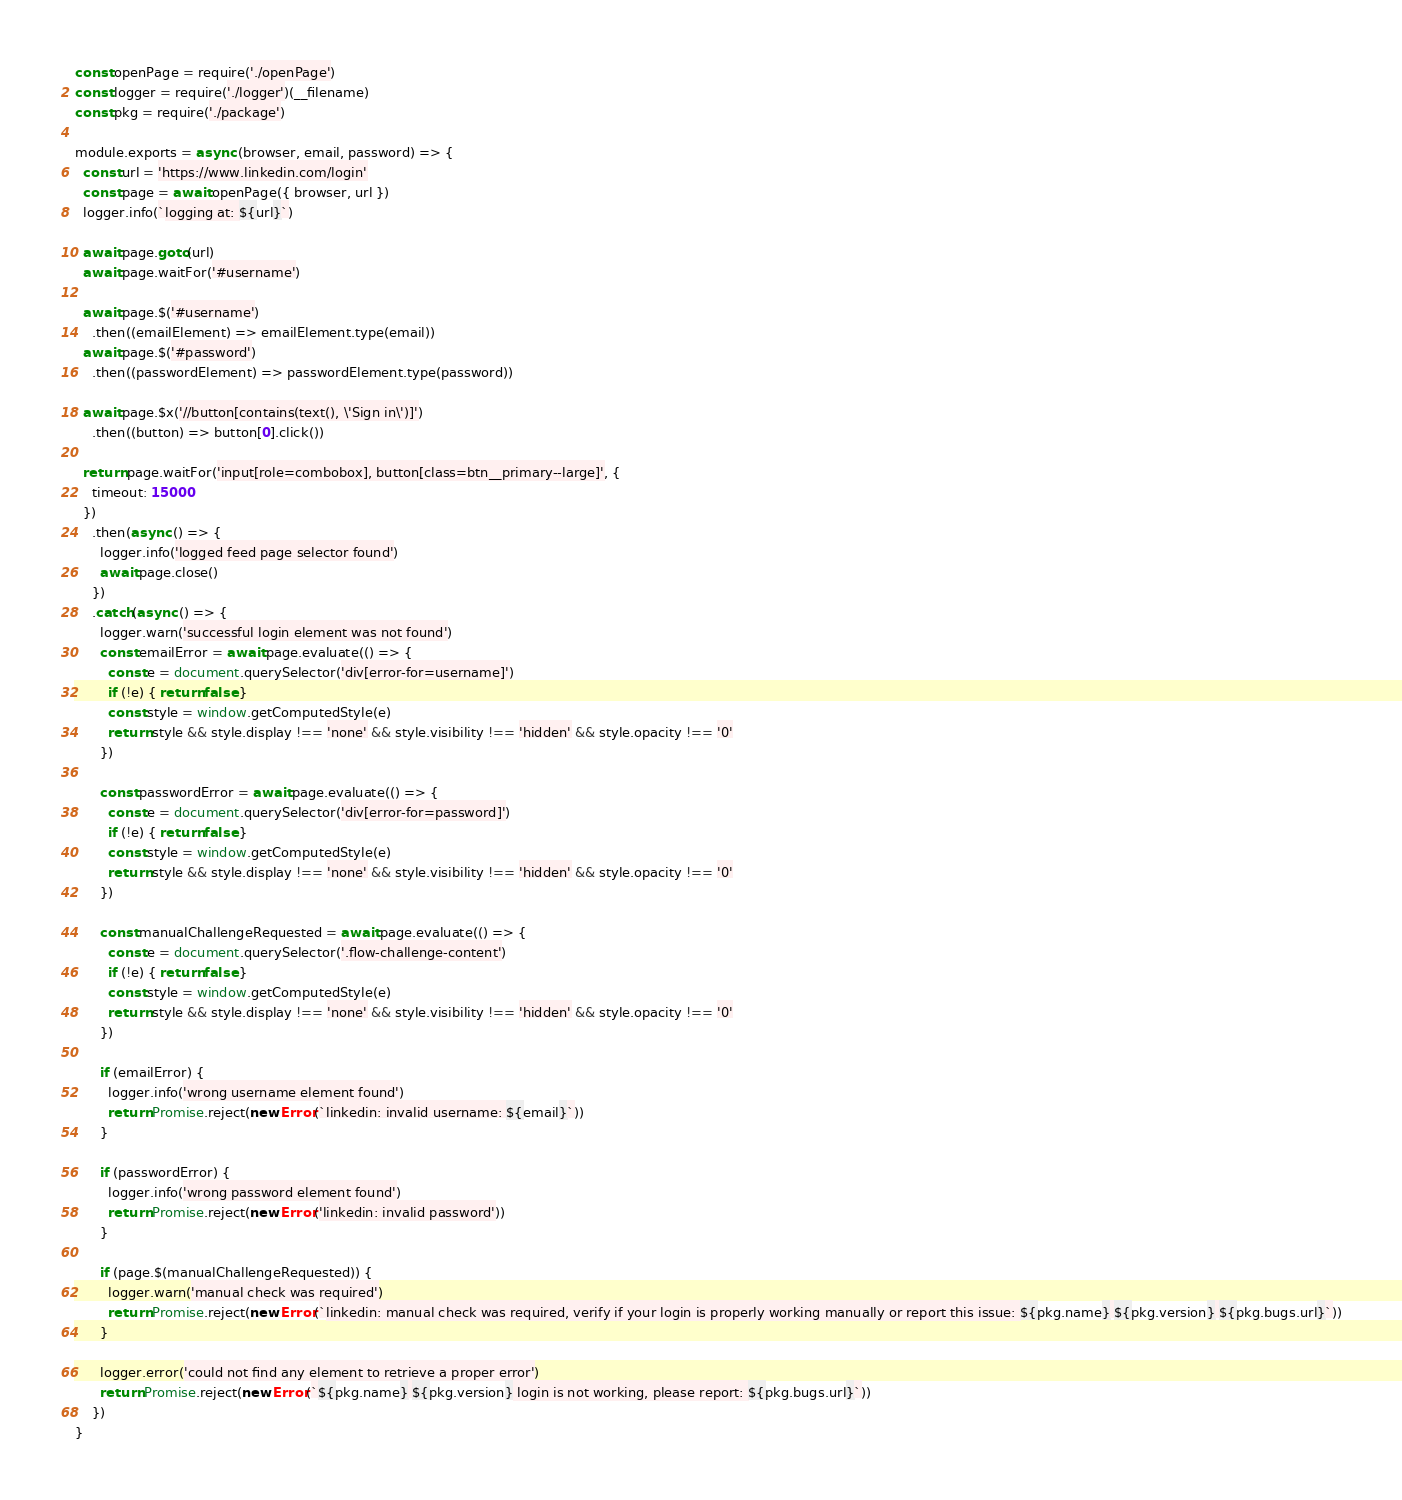Convert code to text. <code><loc_0><loc_0><loc_500><loc_500><_JavaScript_>const openPage = require('./openPage')
const logger = require('./logger')(__filename)
const pkg = require('./package')

module.exports = async (browser, email, password) => {
  const url = 'https://www.linkedin.com/login'
  const page = await openPage({ browser, url })
  logger.info(`logging at: ${url}`)

  await page.goto(url)
  await page.waitFor('#username')

  await page.$('#username')
    .then((emailElement) => emailElement.type(email))
  await page.$('#password')
    .then((passwordElement) => passwordElement.type(password))

  await page.$x('//button[contains(text(), \'Sign in\')]')
    .then((button) => button[0].click())

  return page.waitFor('input[role=combobox], button[class=btn__primary--large]', {
    timeout: 15000
  })
    .then(async () => {
      logger.info('logged feed page selector found')
      await page.close()
    })
    .catch(async () => {
      logger.warn('successful login element was not found')
      const emailError = await page.evaluate(() => {
        const e = document.querySelector('div[error-for=username]')
        if (!e) { return false }
        const style = window.getComputedStyle(e)
        return style && style.display !== 'none' && style.visibility !== 'hidden' && style.opacity !== '0'
      })

      const passwordError = await page.evaluate(() => {
        const e = document.querySelector('div[error-for=password]')
        if (!e) { return false }
        const style = window.getComputedStyle(e)
        return style && style.display !== 'none' && style.visibility !== 'hidden' && style.opacity !== '0'
      })

      const manualChallengeRequested = await page.evaluate(() => {
        const e = document.querySelector('.flow-challenge-content')
        if (!e) { return false }
        const style = window.getComputedStyle(e)
        return style && style.display !== 'none' && style.visibility !== 'hidden' && style.opacity !== '0'
      })

      if (emailError) {
        logger.info('wrong username element found')
        return Promise.reject(new Error(`linkedin: invalid username: ${email}`))
      }

      if (passwordError) {
        logger.info('wrong password element found')
        return Promise.reject(new Error('linkedin: invalid password'))
      }

      if (page.$(manualChallengeRequested)) {
        logger.warn('manual check was required')
        return Promise.reject(new Error(`linkedin: manual check was required, verify if your login is properly working manually or report this issue: ${pkg.name} ${pkg.version} ${pkg.bugs.url}`))
      }

      logger.error('could not find any element to retrieve a proper error')
      return Promise.reject(new Error(`${pkg.name} ${pkg.version} login is not working, please report: ${pkg.bugs.url}`))
    })
}
</code> 